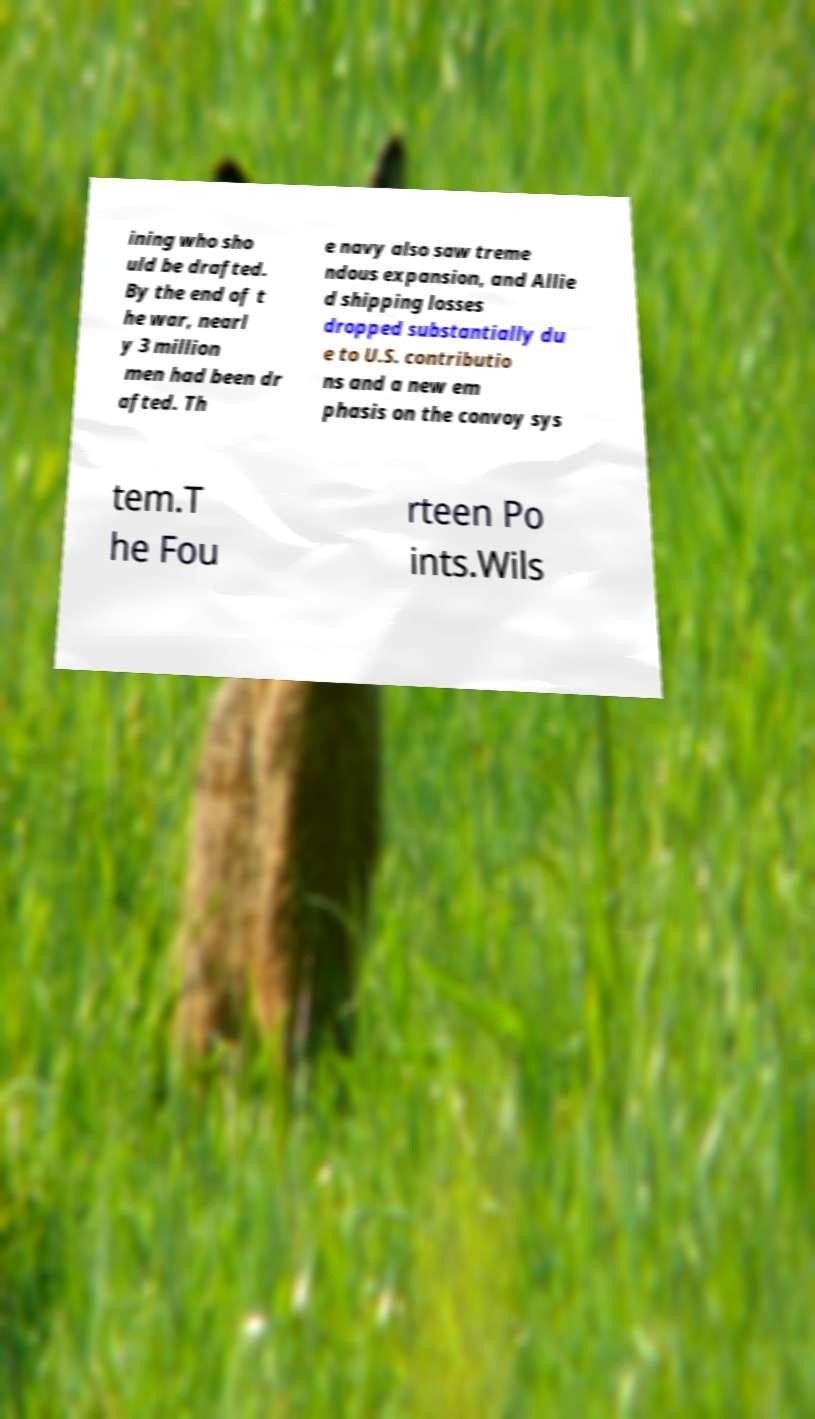Please identify and transcribe the text found in this image. ining who sho uld be drafted. By the end of t he war, nearl y 3 million men had been dr afted. Th e navy also saw treme ndous expansion, and Allie d shipping losses dropped substantially du e to U.S. contributio ns and a new em phasis on the convoy sys tem.T he Fou rteen Po ints.Wils 